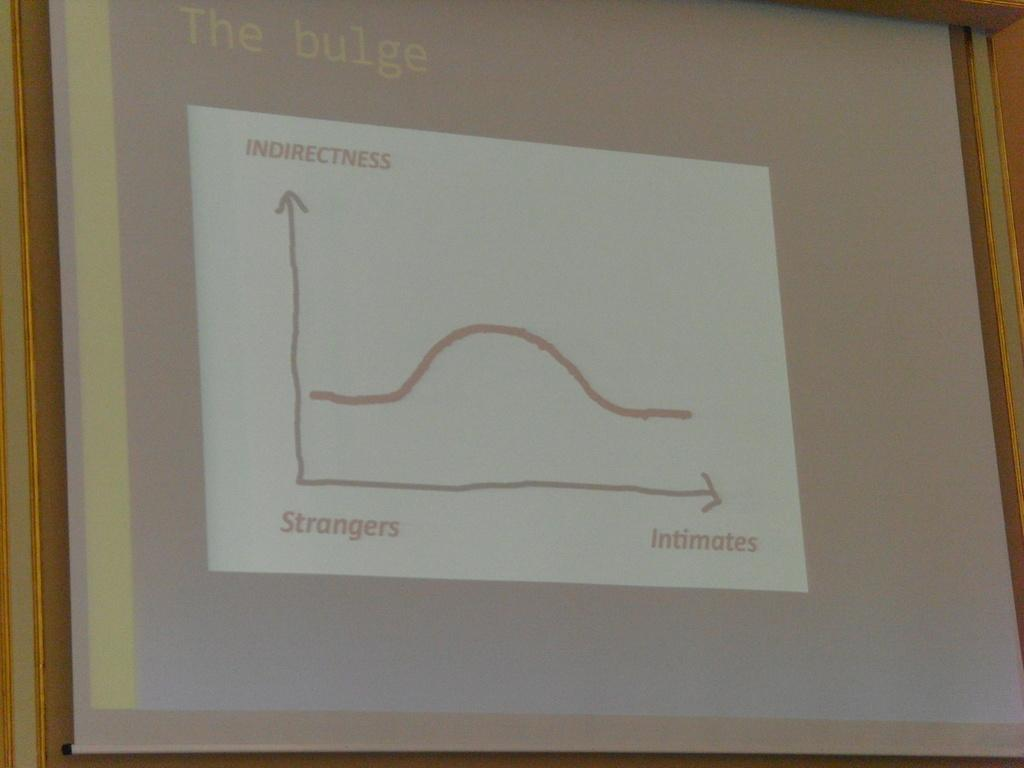<image>
Present a compact description of the photo's key features. A simple graph titled The Bulge, with indirectness and strangers and intimates. 